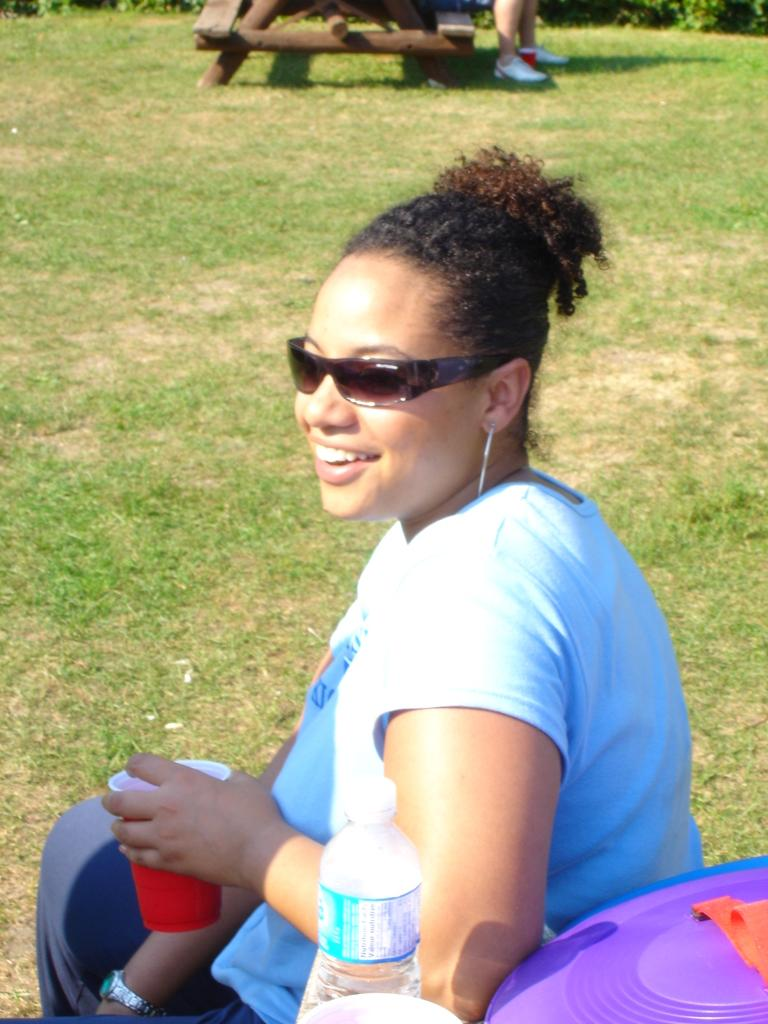Who is the main subject in the image? There is a woman in the image. What is the woman doing in the image? The woman is sitting. What object is the woman holding in her hand? The woman is holding a glass in her hand. What type of basin is the woman using to hold the glass in the image? There is no basin present in the image; the woman is simply holding a glass in her hand. How many stems are visible in the image? There are no stems visible in the image. 